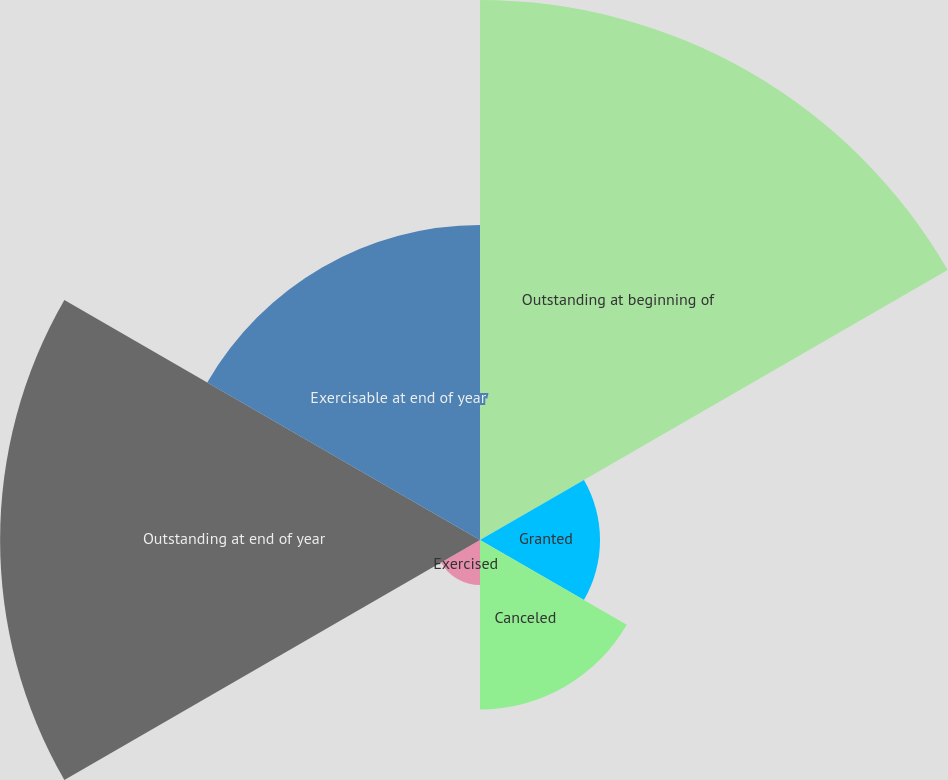<chart> <loc_0><loc_0><loc_500><loc_500><pie_chart><fcel>Outstanding at beginning of<fcel>Granted<fcel>Canceled<fcel>Exercised<fcel>Outstanding at end of year<fcel>Exercisable at end of year<nl><fcel>32.35%<fcel>7.19%<fcel>10.15%<fcel>2.7%<fcel>28.75%<fcel>18.87%<nl></chart> 